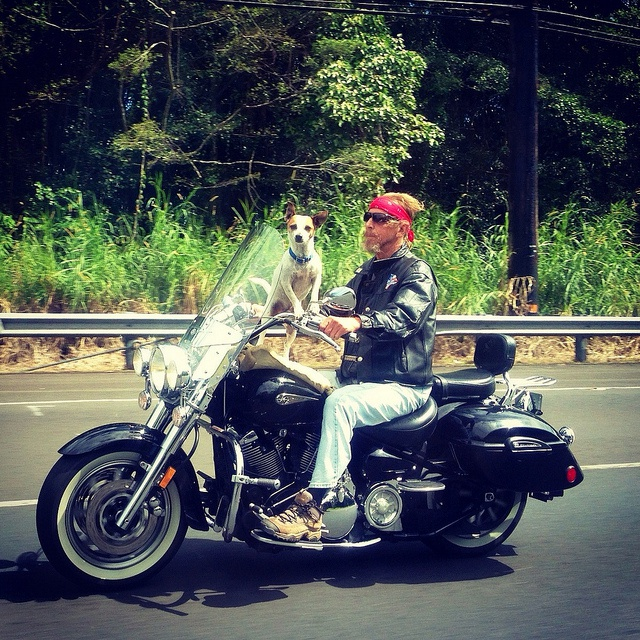Describe the objects in this image and their specific colors. I can see motorcycle in black, navy, beige, and gray tones, people in black, beige, navy, and gray tones, and dog in black, beige, darkgray, and gray tones in this image. 